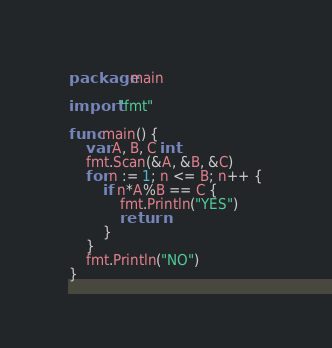Convert code to text. <code><loc_0><loc_0><loc_500><loc_500><_Go_>package main

import "fmt"

func main() {
	var A, B, C int
	fmt.Scan(&A, &B, &C)
	for n := 1; n <= B; n++ {
		if n*A%B == C {
			fmt.Println("YES")
			return
		}
	}
	fmt.Println("NO")
}
</code> 